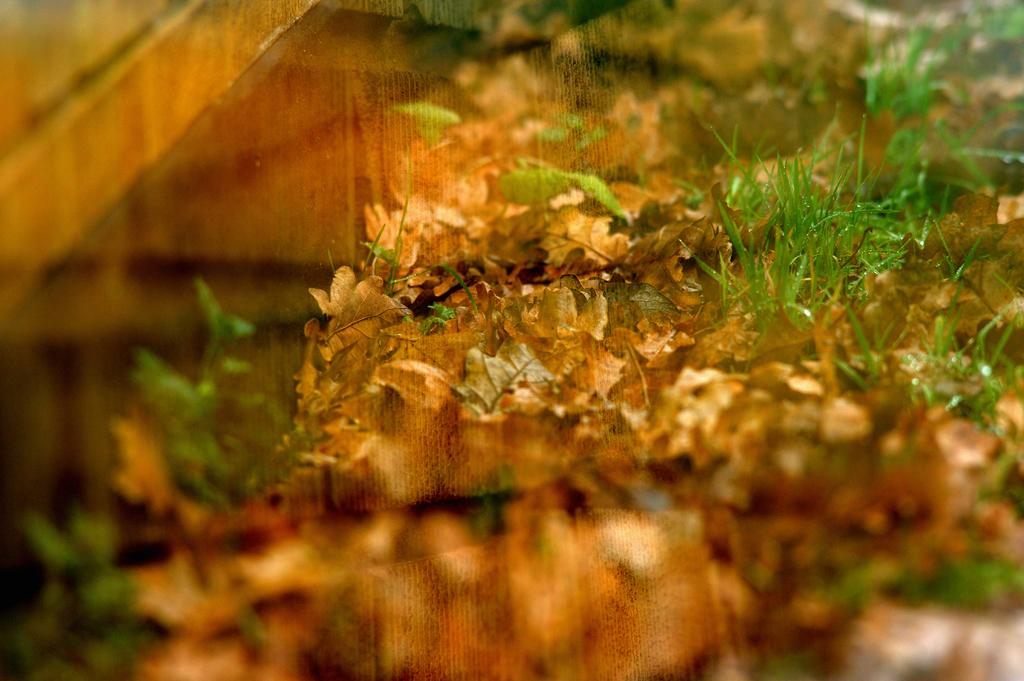What object is present in the image that can hold a liquid? There is a glass in the image. What can be seen in the reflection of the glass? The glass has a reflection of grass and dry leaves. What type of jelly is visible in the image? There is no jelly present in the image. What color is the shirt of the person in the image? There is no person or shirt present in the image. What type of iron object is visible in the image? There is no iron object present in the image. 